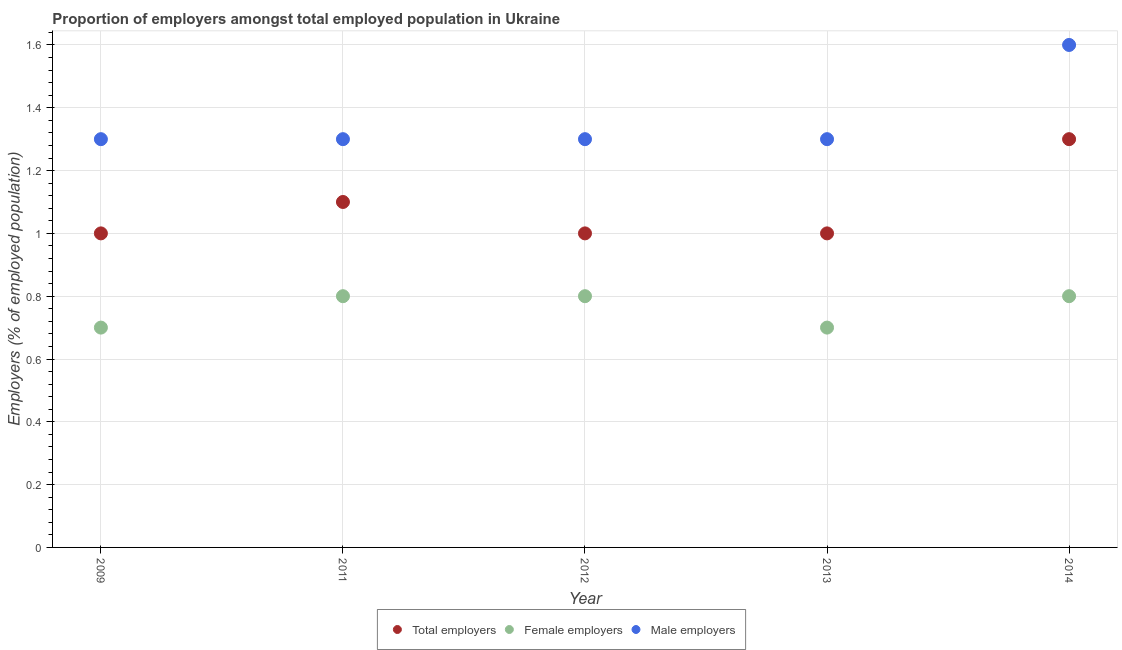Is the number of dotlines equal to the number of legend labels?
Keep it short and to the point. Yes. What is the percentage of female employers in 2012?
Offer a terse response. 0.8. Across all years, what is the maximum percentage of female employers?
Give a very brief answer. 0.8. Across all years, what is the minimum percentage of total employers?
Your response must be concise. 1. In which year was the percentage of female employers maximum?
Offer a terse response. 2011. In which year was the percentage of male employers minimum?
Provide a succinct answer. 2009. What is the total percentage of total employers in the graph?
Provide a succinct answer. 5.4. What is the difference between the percentage of male employers in 2009 and that in 2014?
Offer a terse response. -0.3. What is the difference between the percentage of total employers in 2013 and the percentage of female employers in 2012?
Provide a succinct answer. 0.2. What is the average percentage of female employers per year?
Offer a very short reply. 0.76. In the year 2009, what is the difference between the percentage of female employers and percentage of male employers?
Keep it short and to the point. -0.6. What is the ratio of the percentage of female employers in 2012 to that in 2013?
Provide a succinct answer. 1.14. Is the difference between the percentage of female employers in 2013 and 2014 greater than the difference between the percentage of male employers in 2013 and 2014?
Provide a succinct answer. Yes. What is the difference between the highest and the second highest percentage of total employers?
Ensure brevity in your answer.  0.2. What is the difference between the highest and the lowest percentage of male employers?
Make the answer very short. 0.3. In how many years, is the percentage of female employers greater than the average percentage of female employers taken over all years?
Keep it short and to the point. 3. Is it the case that in every year, the sum of the percentage of total employers and percentage of female employers is greater than the percentage of male employers?
Keep it short and to the point. Yes. Does the percentage of total employers monotonically increase over the years?
Offer a very short reply. No. Is the percentage of male employers strictly greater than the percentage of total employers over the years?
Provide a short and direct response. Yes. How many dotlines are there?
Provide a succinct answer. 3. How many years are there in the graph?
Your answer should be compact. 5. Are the values on the major ticks of Y-axis written in scientific E-notation?
Your answer should be compact. No. Does the graph contain grids?
Offer a very short reply. Yes. What is the title of the graph?
Your answer should be compact. Proportion of employers amongst total employed population in Ukraine. Does "Renewable sources" appear as one of the legend labels in the graph?
Your answer should be very brief. No. What is the label or title of the Y-axis?
Provide a short and direct response. Employers (% of employed population). What is the Employers (% of employed population) of Female employers in 2009?
Your response must be concise. 0.7. What is the Employers (% of employed population) of Male employers in 2009?
Ensure brevity in your answer.  1.3. What is the Employers (% of employed population) in Total employers in 2011?
Offer a terse response. 1.1. What is the Employers (% of employed population) in Female employers in 2011?
Provide a succinct answer. 0.8. What is the Employers (% of employed population) in Male employers in 2011?
Ensure brevity in your answer.  1.3. What is the Employers (% of employed population) of Total employers in 2012?
Keep it short and to the point. 1. What is the Employers (% of employed population) of Female employers in 2012?
Keep it short and to the point. 0.8. What is the Employers (% of employed population) of Male employers in 2012?
Your answer should be compact. 1.3. What is the Employers (% of employed population) in Female employers in 2013?
Provide a succinct answer. 0.7. What is the Employers (% of employed population) in Male employers in 2013?
Make the answer very short. 1.3. What is the Employers (% of employed population) of Total employers in 2014?
Give a very brief answer. 1.3. What is the Employers (% of employed population) in Female employers in 2014?
Your answer should be compact. 0.8. What is the Employers (% of employed population) in Male employers in 2014?
Your answer should be compact. 1.6. Across all years, what is the maximum Employers (% of employed population) of Total employers?
Offer a terse response. 1.3. Across all years, what is the maximum Employers (% of employed population) of Female employers?
Ensure brevity in your answer.  0.8. Across all years, what is the maximum Employers (% of employed population) in Male employers?
Keep it short and to the point. 1.6. Across all years, what is the minimum Employers (% of employed population) of Total employers?
Keep it short and to the point. 1. Across all years, what is the minimum Employers (% of employed population) in Female employers?
Provide a short and direct response. 0.7. Across all years, what is the minimum Employers (% of employed population) in Male employers?
Your answer should be compact. 1.3. What is the total Employers (% of employed population) in Total employers in the graph?
Your answer should be compact. 5.4. What is the total Employers (% of employed population) of Male employers in the graph?
Your answer should be very brief. 6.8. What is the difference between the Employers (% of employed population) in Total employers in 2009 and that in 2011?
Provide a succinct answer. -0.1. What is the difference between the Employers (% of employed population) of Male employers in 2009 and that in 2011?
Your answer should be very brief. 0. What is the difference between the Employers (% of employed population) of Total employers in 2009 and that in 2012?
Offer a very short reply. 0. What is the difference between the Employers (% of employed population) in Female employers in 2009 and that in 2012?
Offer a terse response. -0.1. What is the difference between the Employers (% of employed population) of Male employers in 2009 and that in 2013?
Your answer should be compact. 0. What is the difference between the Employers (% of employed population) in Male employers in 2009 and that in 2014?
Make the answer very short. -0.3. What is the difference between the Employers (% of employed population) in Total employers in 2011 and that in 2012?
Keep it short and to the point. 0.1. What is the difference between the Employers (% of employed population) of Male employers in 2011 and that in 2012?
Give a very brief answer. 0. What is the difference between the Employers (% of employed population) of Female employers in 2011 and that in 2014?
Your response must be concise. 0. What is the difference between the Employers (% of employed population) of Male employers in 2011 and that in 2014?
Your answer should be very brief. -0.3. What is the difference between the Employers (% of employed population) of Total employers in 2012 and that in 2013?
Your response must be concise. 0. What is the difference between the Employers (% of employed population) in Female employers in 2012 and that in 2013?
Your answer should be very brief. 0.1. What is the difference between the Employers (% of employed population) in Male employers in 2012 and that in 2013?
Your response must be concise. 0. What is the difference between the Employers (% of employed population) in Total employers in 2012 and that in 2014?
Ensure brevity in your answer.  -0.3. What is the difference between the Employers (% of employed population) of Female employers in 2012 and that in 2014?
Ensure brevity in your answer.  0. What is the difference between the Employers (% of employed population) of Male employers in 2012 and that in 2014?
Give a very brief answer. -0.3. What is the difference between the Employers (% of employed population) in Total employers in 2013 and that in 2014?
Offer a very short reply. -0.3. What is the difference between the Employers (% of employed population) in Total employers in 2009 and the Employers (% of employed population) in Female employers in 2011?
Give a very brief answer. 0.2. What is the difference between the Employers (% of employed population) in Total employers in 2009 and the Employers (% of employed population) in Male employers in 2013?
Your answer should be compact. -0.3. What is the difference between the Employers (% of employed population) in Total employers in 2009 and the Employers (% of employed population) in Female employers in 2014?
Provide a short and direct response. 0.2. What is the difference between the Employers (% of employed population) in Total employers in 2009 and the Employers (% of employed population) in Male employers in 2014?
Ensure brevity in your answer.  -0.6. What is the difference between the Employers (% of employed population) of Total employers in 2011 and the Employers (% of employed population) of Male employers in 2012?
Your response must be concise. -0.2. What is the difference between the Employers (% of employed population) of Female employers in 2011 and the Employers (% of employed population) of Male employers in 2012?
Offer a very short reply. -0.5. What is the difference between the Employers (% of employed population) of Total employers in 2011 and the Employers (% of employed population) of Female employers in 2014?
Provide a succinct answer. 0.3. What is the difference between the Employers (% of employed population) in Total employers in 2012 and the Employers (% of employed population) in Female employers in 2013?
Give a very brief answer. 0.3. What is the difference between the Employers (% of employed population) of Total employers in 2012 and the Employers (% of employed population) of Male employers in 2014?
Ensure brevity in your answer.  -0.6. What is the difference between the Employers (% of employed population) in Female employers in 2012 and the Employers (% of employed population) in Male employers in 2014?
Ensure brevity in your answer.  -0.8. What is the difference between the Employers (% of employed population) in Total employers in 2013 and the Employers (% of employed population) in Male employers in 2014?
Give a very brief answer. -0.6. What is the difference between the Employers (% of employed population) in Female employers in 2013 and the Employers (% of employed population) in Male employers in 2014?
Give a very brief answer. -0.9. What is the average Employers (% of employed population) of Female employers per year?
Ensure brevity in your answer.  0.76. What is the average Employers (% of employed population) in Male employers per year?
Keep it short and to the point. 1.36. In the year 2009, what is the difference between the Employers (% of employed population) of Total employers and Employers (% of employed population) of Female employers?
Provide a succinct answer. 0.3. In the year 2009, what is the difference between the Employers (% of employed population) of Female employers and Employers (% of employed population) of Male employers?
Give a very brief answer. -0.6. In the year 2011, what is the difference between the Employers (% of employed population) in Total employers and Employers (% of employed population) in Female employers?
Offer a very short reply. 0.3. In the year 2011, what is the difference between the Employers (% of employed population) of Female employers and Employers (% of employed population) of Male employers?
Your answer should be very brief. -0.5. In the year 2012, what is the difference between the Employers (% of employed population) in Total employers and Employers (% of employed population) in Female employers?
Your answer should be compact. 0.2. In the year 2012, what is the difference between the Employers (% of employed population) in Total employers and Employers (% of employed population) in Male employers?
Provide a short and direct response. -0.3. In the year 2013, what is the difference between the Employers (% of employed population) in Total employers and Employers (% of employed population) in Female employers?
Your answer should be very brief. 0.3. In the year 2013, what is the difference between the Employers (% of employed population) in Total employers and Employers (% of employed population) in Male employers?
Give a very brief answer. -0.3. In the year 2014, what is the difference between the Employers (% of employed population) in Total employers and Employers (% of employed population) in Male employers?
Make the answer very short. -0.3. In the year 2014, what is the difference between the Employers (% of employed population) in Female employers and Employers (% of employed population) in Male employers?
Offer a terse response. -0.8. What is the ratio of the Employers (% of employed population) of Total employers in 2009 to that in 2011?
Make the answer very short. 0.91. What is the ratio of the Employers (% of employed population) in Female employers in 2009 to that in 2011?
Keep it short and to the point. 0.88. What is the ratio of the Employers (% of employed population) of Male employers in 2009 to that in 2011?
Offer a terse response. 1. What is the ratio of the Employers (% of employed population) in Female employers in 2009 to that in 2012?
Provide a succinct answer. 0.88. What is the ratio of the Employers (% of employed population) of Female employers in 2009 to that in 2013?
Give a very brief answer. 1. What is the ratio of the Employers (% of employed population) of Male employers in 2009 to that in 2013?
Your answer should be compact. 1. What is the ratio of the Employers (% of employed population) of Total employers in 2009 to that in 2014?
Ensure brevity in your answer.  0.77. What is the ratio of the Employers (% of employed population) of Female employers in 2009 to that in 2014?
Provide a succinct answer. 0.88. What is the ratio of the Employers (% of employed population) in Male employers in 2009 to that in 2014?
Provide a short and direct response. 0.81. What is the ratio of the Employers (% of employed population) of Total employers in 2011 to that in 2012?
Give a very brief answer. 1.1. What is the ratio of the Employers (% of employed population) of Male employers in 2011 to that in 2012?
Keep it short and to the point. 1. What is the ratio of the Employers (% of employed population) of Total employers in 2011 to that in 2013?
Provide a short and direct response. 1.1. What is the ratio of the Employers (% of employed population) of Total employers in 2011 to that in 2014?
Keep it short and to the point. 0.85. What is the ratio of the Employers (% of employed population) in Female employers in 2011 to that in 2014?
Provide a succinct answer. 1. What is the ratio of the Employers (% of employed population) in Male employers in 2011 to that in 2014?
Provide a succinct answer. 0.81. What is the ratio of the Employers (% of employed population) of Total employers in 2012 to that in 2014?
Offer a very short reply. 0.77. What is the ratio of the Employers (% of employed population) in Male employers in 2012 to that in 2014?
Give a very brief answer. 0.81. What is the ratio of the Employers (% of employed population) in Total employers in 2013 to that in 2014?
Provide a short and direct response. 0.77. What is the ratio of the Employers (% of employed population) in Male employers in 2013 to that in 2014?
Make the answer very short. 0.81. What is the difference between the highest and the lowest Employers (% of employed population) in Male employers?
Offer a very short reply. 0.3. 